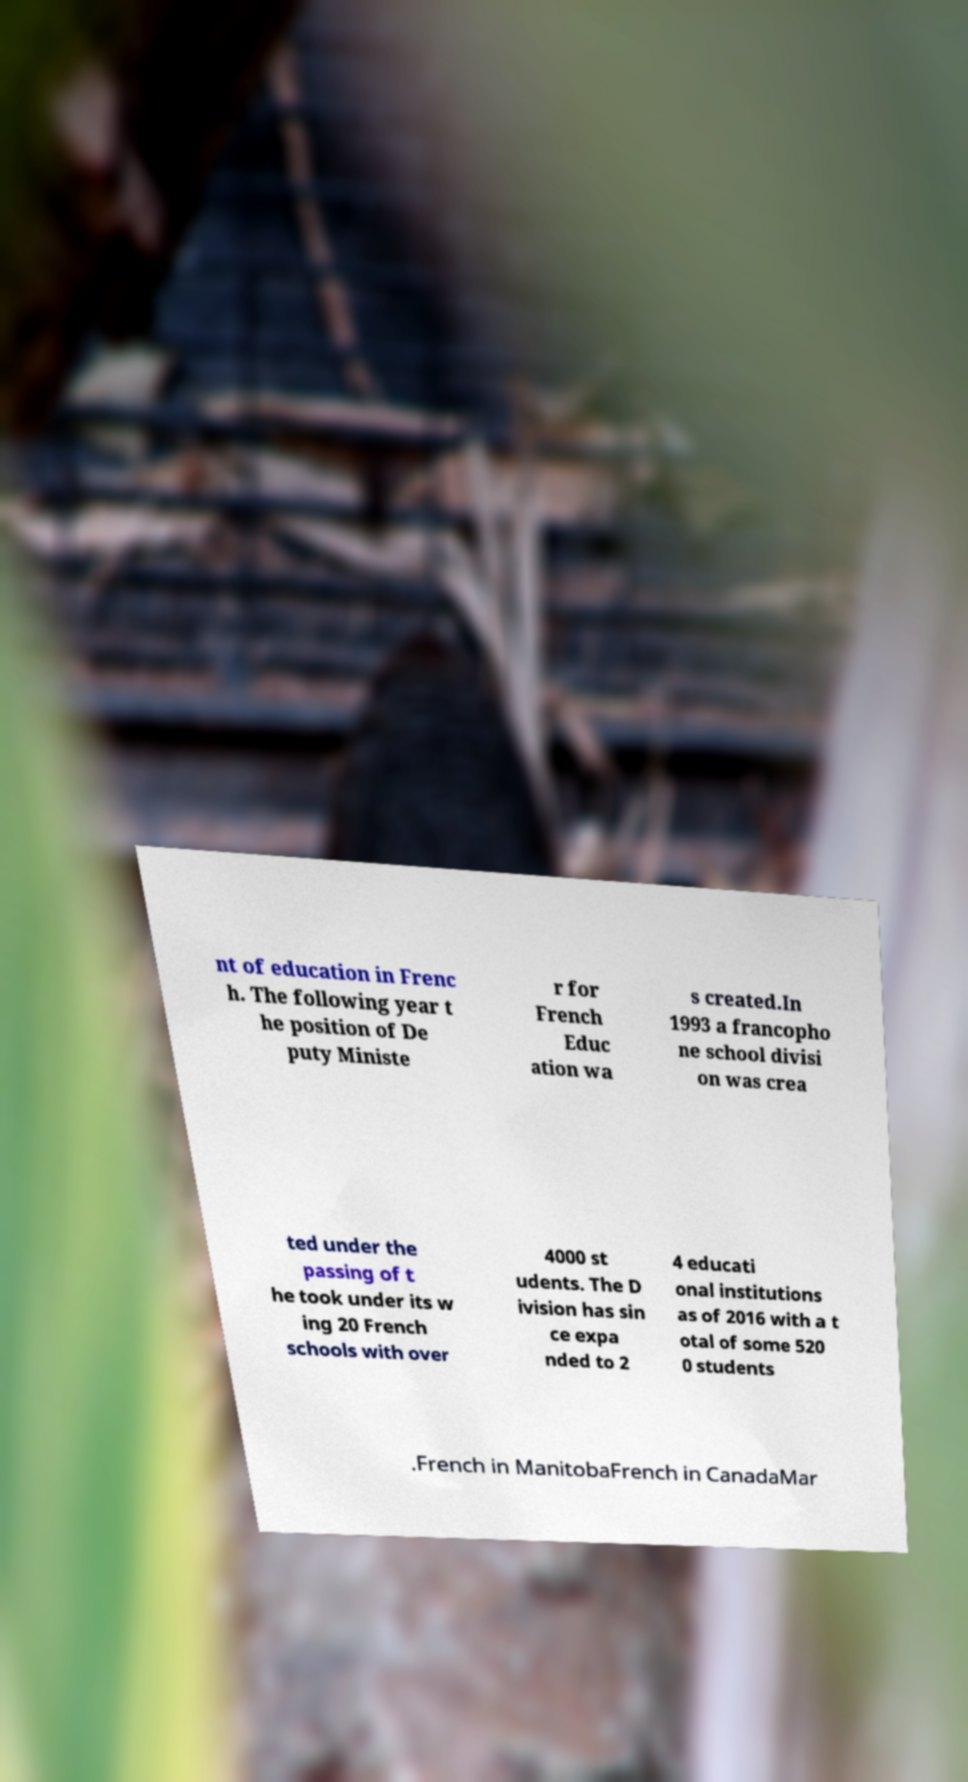There's text embedded in this image that I need extracted. Can you transcribe it verbatim? nt of education in Frenc h. The following year t he position of De puty Ministe r for French Educ ation wa s created.In 1993 a francopho ne school divisi on was crea ted under the passing of t he took under its w ing 20 French schools with over 4000 st udents. The D ivision has sin ce expa nded to 2 4 educati onal institutions as of 2016 with a t otal of some 520 0 students .French in ManitobaFrench in CanadaMar 